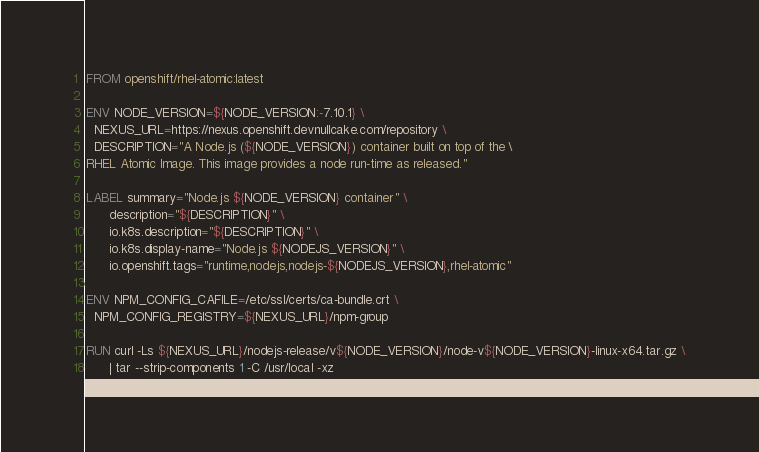Convert code to text. <code><loc_0><loc_0><loc_500><loc_500><_Dockerfile_>FROM openshift/rhel-atomic:latest

ENV NODE_VERSION=${NODE_VERSION:-7.10.1} \
  NEXUS_URL=https://nexus.openshift.devnullcake.com/repository \
  DESCRIPTION="A Node.js (${NODE_VERSION}) container built on top of the \
RHEL Atomic Image. This image provides a node run-time as released."

LABEL summary="Node.js ${NODE_VERSION} container" \
      description="${DESCRIPTION}" \
      io.k8s.description="${DESCRIPTION}" \
      io.k8s.display-name="Node.js ${NODEJS_VERSION}" \
      io.openshift.tags="runtime,nodejs,nodejs-${NODEJS_VERSION},rhel-atomic"

ENV NPM_CONFIG_CAFILE=/etc/ssl/certs/ca-bundle.crt \
  NPM_CONFIG_REGISTRY=${NEXUS_URL}/npm-group

RUN curl -Ls ${NEXUS_URL}/nodejs-release/v${NODE_VERSION}/node-v${NODE_VERSION}-linux-x64.tar.gz \
      | tar --strip-components 1 -C /usr/local -xz
</code> 